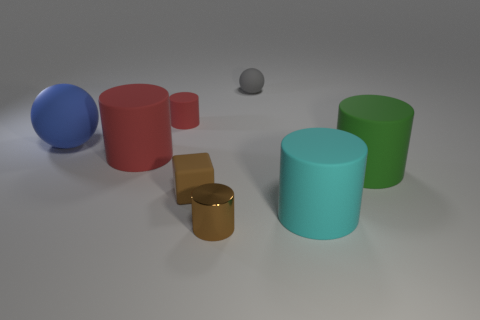Subtract all green cylinders. How many cylinders are left? 4 Subtract all brown cylinders. How many cylinders are left? 4 Subtract all purple cylinders. Subtract all gray cubes. How many cylinders are left? 5 Add 1 blue cylinders. How many objects exist? 9 Subtract all cubes. How many objects are left? 7 Subtract 0 yellow cubes. How many objects are left? 8 Subtract all gray metal objects. Subtract all blue spheres. How many objects are left? 7 Add 3 big green rubber objects. How many big green rubber objects are left? 4 Add 5 cyan matte cylinders. How many cyan matte cylinders exist? 6 